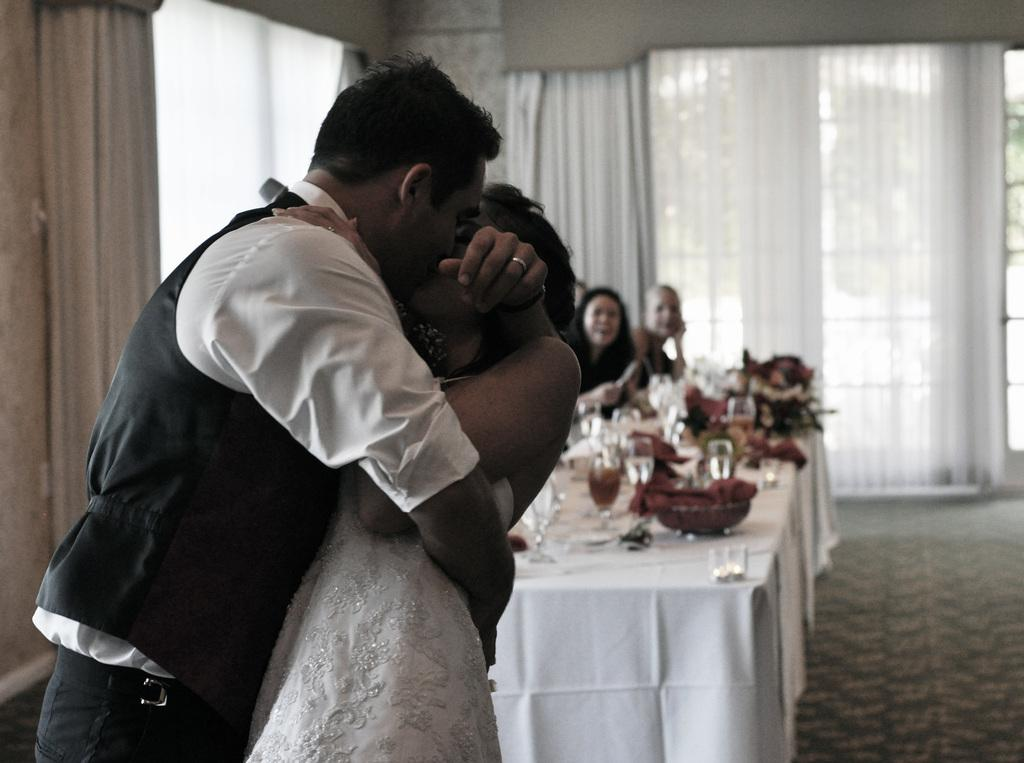Who are the two people in the image? There is a man and a woman in the image. What are the man and woman doing in the image? The man and woman are kissing. What is on the table in the image? The table has food and glasses on it. Where might this image have been taken? The setting appears to be a wedding hall. What type of lip product is the woman wearing in the image? There is no information about lip products in the image, so it cannot be determined. What sense is being stimulated by the man and woman in the image? The image does not provide information about senses being stimulated; it simply shows a man and woman kissing. 